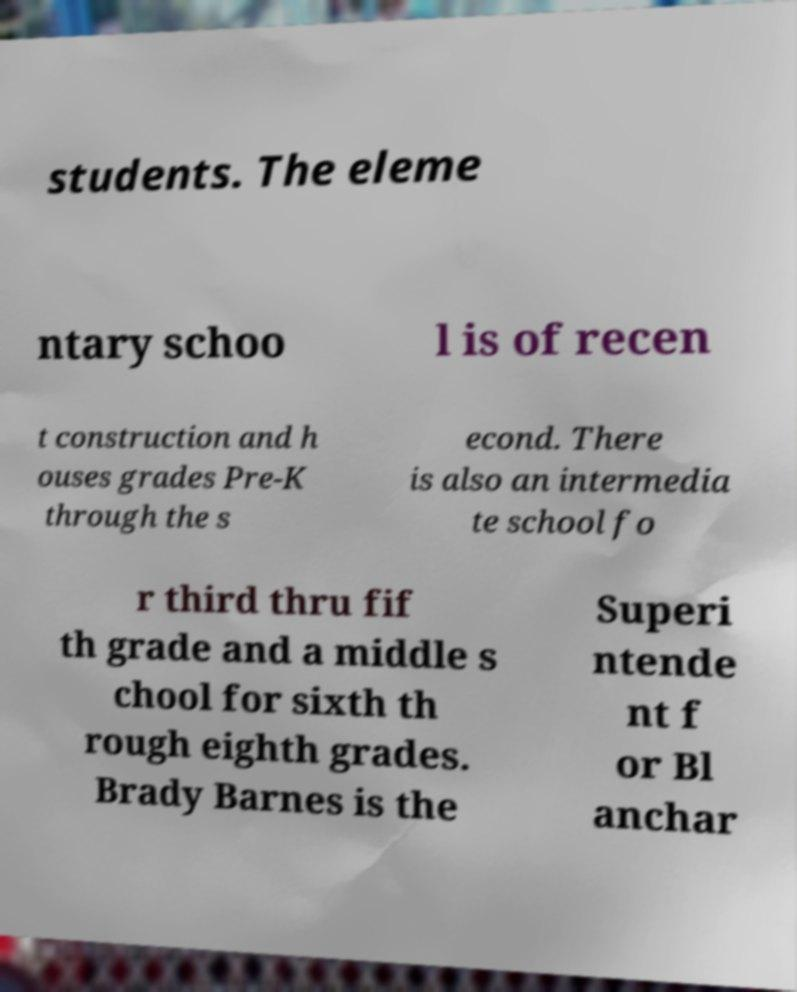Could you assist in decoding the text presented in this image and type it out clearly? students. The eleme ntary schoo l is of recen t construction and h ouses grades Pre-K through the s econd. There is also an intermedia te school fo r third thru fif th grade and a middle s chool for sixth th rough eighth grades. Brady Barnes is the Superi ntende nt f or Bl anchar 